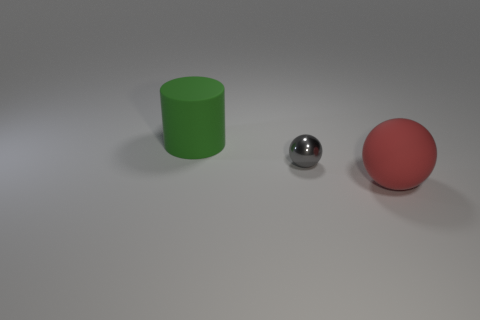Can you discuss the composition and balance of the elements within this image? Certainly! The image composition features three primary objects - a cylinder, a sphere, and a small shiny ball, each with a distinctive color and texture. They are arranged asymmetrically but with balance, as the larger objects are spread out, leaving negative space in the center and right side of the image. This layout guides the viewer's eye across the scene and creates a visual equilibrium. 